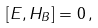<formula> <loc_0><loc_0><loc_500><loc_500>[ E , H _ { B } ] = 0 \, ,</formula> 